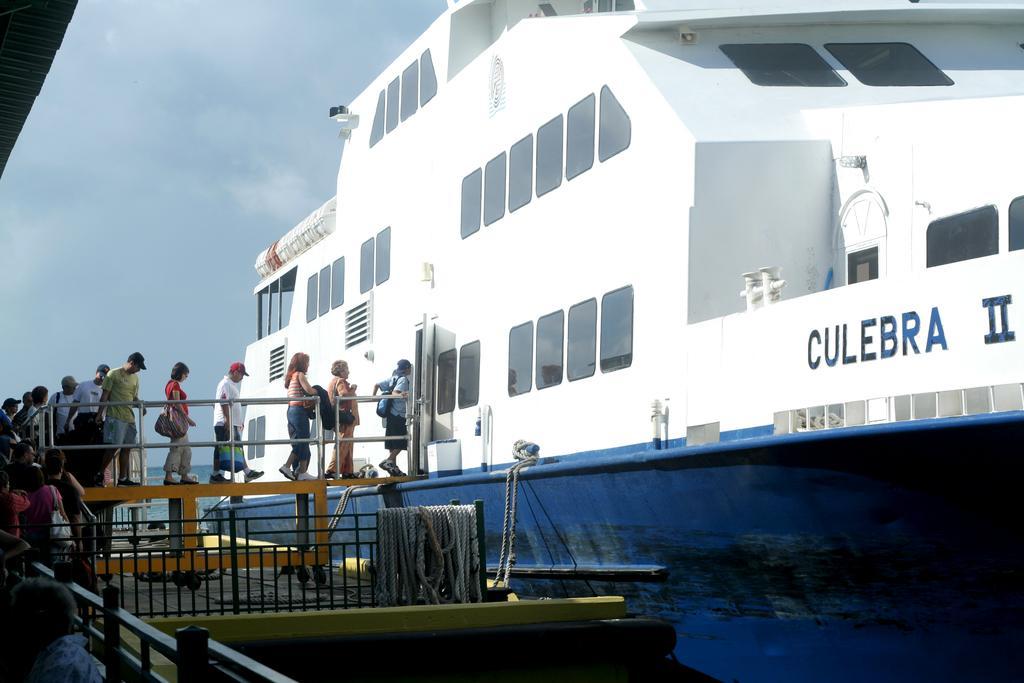Please provide a concise description of this image. In this image we can see a ship. And we can see the people. And we can see the bridge. And we can see the metal railing and the rope. And we can see the sky. 